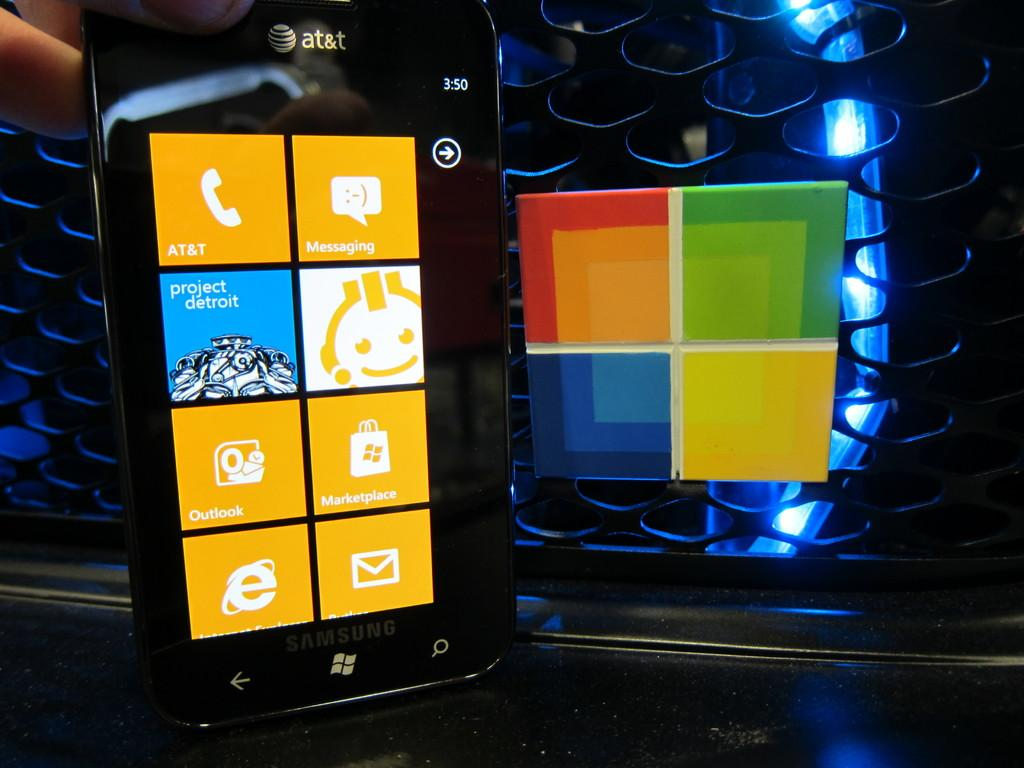<image>
Render a clear and concise summary of the photo. black at&t windows phone with time showing 3:50 